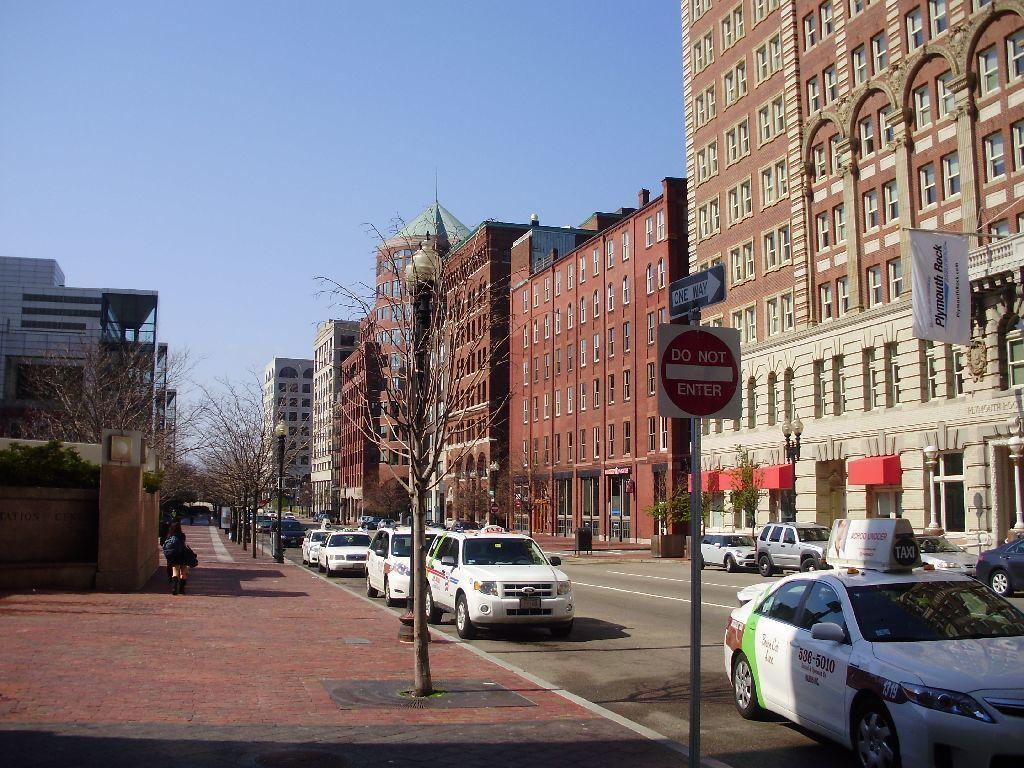How would you summarize this image in a sentence or two? In the foreground of the picture, there is a sign board. On the left, there is a pavement and a person walking on it. We can also see few buildings and trees on the left. On the right, there are buildings, poles, trees, vehicles moving on the road, a flag and the sky at the top. 